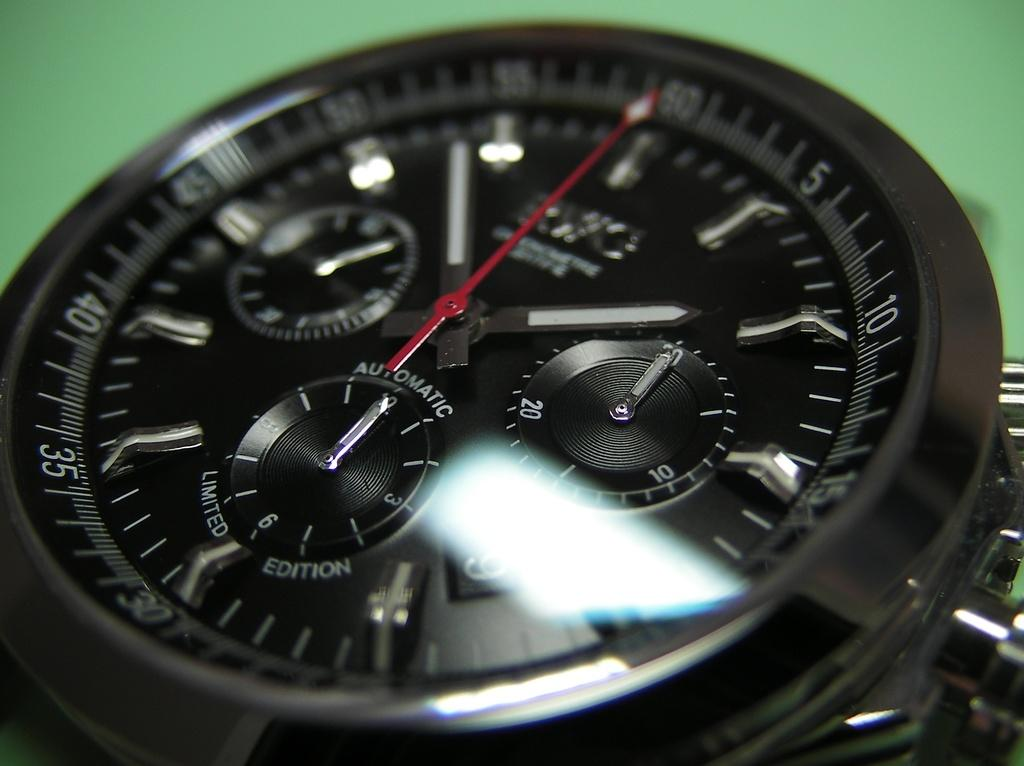<image>
Relay a brief, clear account of the picture shown. A round black watch face with the word automatic on it 